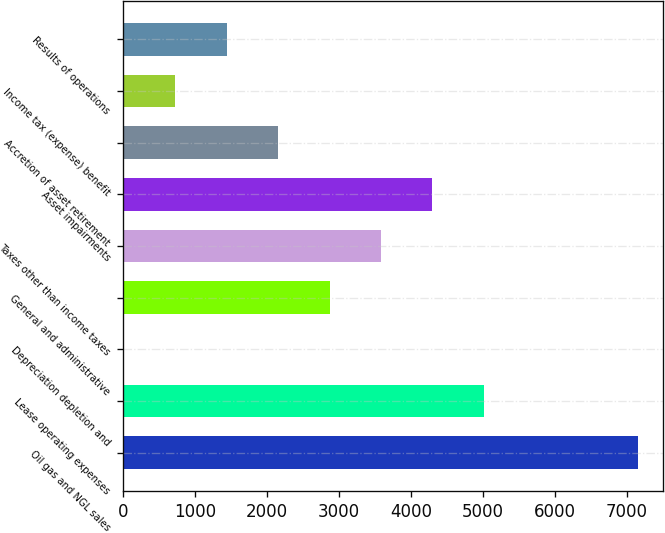Convert chart to OTSL. <chart><loc_0><loc_0><loc_500><loc_500><bar_chart><fcel>Oil gas and NGL sales<fcel>Lease operating expenses<fcel>Depreciation depletion and<fcel>General and administrative<fcel>Taxes other than income taxes<fcel>Asset impairments<fcel>Accretion of asset retirement<fcel>Income tax (expense) benefit<fcel>Results of operations<nl><fcel>7153<fcel>5010.15<fcel>10.12<fcel>2867.28<fcel>3581.57<fcel>4295.86<fcel>2152.99<fcel>724.41<fcel>1438.7<nl></chart> 